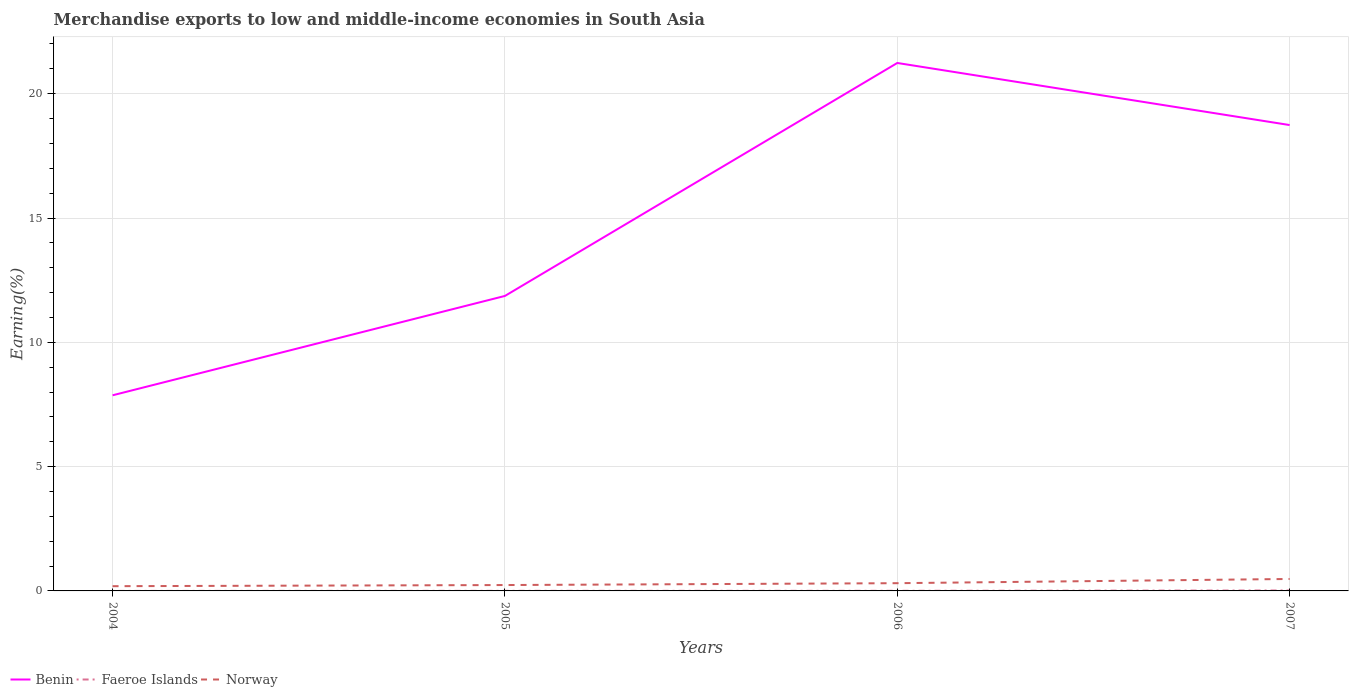Does the line corresponding to Faeroe Islands intersect with the line corresponding to Norway?
Give a very brief answer. No. Across all years, what is the maximum percentage of amount earned from merchandise exports in Faeroe Islands?
Your response must be concise. 0. In which year was the percentage of amount earned from merchandise exports in Faeroe Islands maximum?
Offer a very short reply. 2004. What is the total percentage of amount earned from merchandise exports in Benin in the graph?
Ensure brevity in your answer.  -13.37. What is the difference between the highest and the second highest percentage of amount earned from merchandise exports in Benin?
Ensure brevity in your answer.  13.37. What is the difference between the highest and the lowest percentage of amount earned from merchandise exports in Norway?
Your answer should be very brief. 2. Is the percentage of amount earned from merchandise exports in Benin strictly greater than the percentage of amount earned from merchandise exports in Faeroe Islands over the years?
Offer a very short reply. No. How many years are there in the graph?
Offer a very short reply. 4. What is the difference between two consecutive major ticks on the Y-axis?
Make the answer very short. 5. Does the graph contain grids?
Give a very brief answer. Yes. What is the title of the graph?
Your answer should be very brief. Merchandise exports to low and middle-income economies in South Asia. What is the label or title of the Y-axis?
Your response must be concise. Earning(%). What is the Earning(%) in Benin in 2004?
Give a very brief answer. 7.87. What is the Earning(%) in Faeroe Islands in 2004?
Offer a terse response. 0. What is the Earning(%) in Norway in 2004?
Give a very brief answer. 0.19. What is the Earning(%) of Benin in 2005?
Offer a very short reply. 11.86. What is the Earning(%) in Faeroe Islands in 2005?
Provide a succinct answer. 0. What is the Earning(%) of Norway in 2005?
Keep it short and to the point. 0.24. What is the Earning(%) in Benin in 2006?
Provide a short and direct response. 21.24. What is the Earning(%) of Faeroe Islands in 2006?
Keep it short and to the point. 0. What is the Earning(%) in Norway in 2006?
Offer a very short reply. 0.31. What is the Earning(%) of Benin in 2007?
Ensure brevity in your answer.  18.74. What is the Earning(%) of Faeroe Islands in 2007?
Offer a very short reply. 0.02. What is the Earning(%) in Norway in 2007?
Your response must be concise. 0.48. Across all years, what is the maximum Earning(%) of Benin?
Provide a succinct answer. 21.24. Across all years, what is the maximum Earning(%) of Faeroe Islands?
Your response must be concise. 0.02. Across all years, what is the maximum Earning(%) of Norway?
Ensure brevity in your answer.  0.48. Across all years, what is the minimum Earning(%) in Benin?
Your answer should be compact. 7.87. Across all years, what is the minimum Earning(%) in Faeroe Islands?
Provide a succinct answer. 0. Across all years, what is the minimum Earning(%) in Norway?
Provide a short and direct response. 0.19. What is the total Earning(%) of Benin in the graph?
Provide a succinct answer. 59.71. What is the total Earning(%) of Faeroe Islands in the graph?
Your response must be concise. 0.03. What is the total Earning(%) in Norway in the graph?
Provide a succinct answer. 1.22. What is the difference between the Earning(%) in Benin in 2004 and that in 2005?
Offer a terse response. -4. What is the difference between the Earning(%) of Faeroe Islands in 2004 and that in 2005?
Ensure brevity in your answer.  -0. What is the difference between the Earning(%) in Norway in 2004 and that in 2005?
Offer a terse response. -0.05. What is the difference between the Earning(%) of Benin in 2004 and that in 2006?
Provide a succinct answer. -13.37. What is the difference between the Earning(%) of Faeroe Islands in 2004 and that in 2006?
Offer a very short reply. -0. What is the difference between the Earning(%) in Norway in 2004 and that in 2006?
Your response must be concise. -0.12. What is the difference between the Earning(%) in Benin in 2004 and that in 2007?
Offer a very short reply. -10.87. What is the difference between the Earning(%) of Faeroe Islands in 2004 and that in 2007?
Keep it short and to the point. -0.02. What is the difference between the Earning(%) in Norway in 2004 and that in 2007?
Offer a very short reply. -0.29. What is the difference between the Earning(%) in Benin in 2005 and that in 2006?
Ensure brevity in your answer.  -9.37. What is the difference between the Earning(%) in Faeroe Islands in 2005 and that in 2006?
Make the answer very short. -0. What is the difference between the Earning(%) in Norway in 2005 and that in 2006?
Provide a succinct answer. -0.07. What is the difference between the Earning(%) of Benin in 2005 and that in 2007?
Your answer should be very brief. -6.87. What is the difference between the Earning(%) in Faeroe Islands in 2005 and that in 2007?
Your response must be concise. -0.01. What is the difference between the Earning(%) in Norway in 2005 and that in 2007?
Provide a short and direct response. -0.24. What is the difference between the Earning(%) in Benin in 2006 and that in 2007?
Your response must be concise. 2.5. What is the difference between the Earning(%) of Faeroe Islands in 2006 and that in 2007?
Your response must be concise. -0.01. What is the difference between the Earning(%) of Norway in 2006 and that in 2007?
Provide a succinct answer. -0.17. What is the difference between the Earning(%) in Benin in 2004 and the Earning(%) in Faeroe Islands in 2005?
Provide a succinct answer. 7.86. What is the difference between the Earning(%) of Benin in 2004 and the Earning(%) of Norway in 2005?
Offer a very short reply. 7.63. What is the difference between the Earning(%) in Faeroe Islands in 2004 and the Earning(%) in Norway in 2005?
Make the answer very short. -0.24. What is the difference between the Earning(%) of Benin in 2004 and the Earning(%) of Faeroe Islands in 2006?
Keep it short and to the point. 7.86. What is the difference between the Earning(%) of Benin in 2004 and the Earning(%) of Norway in 2006?
Offer a terse response. 7.56. What is the difference between the Earning(%) of Faeroe Islands in 2004 and the Earning(%) of Norway in 2006?
Provide a succinct answer. -0.31. What is the difference between the Earning(%) in Benin in 2004 and the Earning(%) in Faeroe Islands in 2007?
Your answer should be very brief. 7.85. What is the difference between the Earning(%) in Benin in 2004 and the Earning(%) in Norway in 2007?
Your answer should be very brief. 7.39. What is the difference between the Earning(%) in Faeroe Islands in 2004 and the Earning(%) in Norway in 2007?
Provide a succinct answer. -0.48. What is the difference between the Earning(%) in Benin in 2005 and the Earning(%) in Faeroe Islands in 2006?
Provide a succinct answer. 11.86. What is the difference between the Earning(%) in Benin in 2005 and the Earning(%) in Norway in 2006?
Offer a very short reply. 11.55. What is the difference between the Earning(%) of Faeroe Islands in 2005 and the Earning(%) of Norway in 2006?
Ensure brevity in your answer.  -0.31. What is the difference between the Earning(%) of Benin in 2005 and the Earning(%) of Faeroe Islands in 2007?
Provide a short and direct response. 11.85. What is the difference between the Earning(%) of Benin in 2005 and the Earning(%) of Norway in 2007?
Keep it short and to the point. 11.38. What is the difference between the Earning(%) in Faeroe Islands in 2005 and the Earning(%) in Norway in 2007?
Offer a very short reply. -0.48. What is the difference between the Earning(%) in Benin in 2006 and the Earning(%) in Faeroe Islands in 2007?
Your response must be concise. 21.22. What is the difference between the Earning(%) in Benin in 2006 and the Earning(%) in Norway in 2007?
Offer a terse response. 20.76. What is the difference between the Earning(%) of Faeroe Islands in 2006 and the Earning(%) of Norway in 2007?
Offer a terse response. -0.48. What is the average Earning(%) in Benin per year?
Keep it short and to the point. 14.93. What is the average Earning(%) in Faeroe Islands per year?
Make the answer very short. 0.01. What is the average Earning(%) in Norway per year?
Your answer should be very brief. 0.3. In the year 2004, what is the difference between the Earning(%) in Benin and Earning(%) in Faeroe Islands?
Provide a succinct answer. 7.87. In the year 2004, what is the difference between the Earning(%) of Benin and Earning(%) of Norway?
Provide a succinct answer. 7.68. In the year 2004, what is the difference between the Earning(%) in Faeroe Islands and Earning(%) in Norway?
Give a very brief answer. -0.19. In the year 2005, what is the difference between the Earning(%) in Benin and Earning(%) in Faeroe Islands?
Make the answer very short. 11.86. In the year 2005, what is the difference between the Earning(%) in Benin and Earning(%) in Norway?
Provide a succinct answer. 11.63. In the year 2005, what is the difference between the Earning(%) of Faeroe Islands and Earning(%) of Norway?
Keep it short and to the point. -0.23. In the year 2006, what is the difference between the Earning(%) in Benin and Earning(%) in Faeroe Islands?
Ensure brevity in your answer.  21.23. In the year 2006, what is the difference between the Earning(%) of Benin and Earning(%) of Norway?
Provide a succinct answer. 20.92. In the year 2006, what is the difference between the Earning(%) of Faeroe Islands and Earning(%) of Norway?
Provide a short and direct response. -0.31. In the year 2007, what is the difference between the Earning(%) in Benin and Earning(%) in Faeroe Islands?
Make the answer very short. 18.72. In the year 2007, what is the difference between the Earning(%) of Benin and Earning(%) of Norway?
Provide a succinct answer. 18.26. In the year 2007, what is the difference between the Earning(%) of Faeroe Islands and Earning(%) of Norway?
Your answer should be very brief. -0.46. What is the ratio of the Earning(%) in Benin in 2004 to that in 2005?
Ensure brevity in your answer.  0.66. What is the ratio of the Earning(%) of Faeroe Islands in 2004 to that in 2005?
Ensure brevity in your answer.  0.08. What is the ratio of the Earning(%) in Norway in 2004 to that in 2005?
Keep it short and to the point. 0.81. What is the ratio of the Earning(%) of Benin in 2004 to that in 2006?
Make the answer very short. 0.37. What is the ratio of the Earning(%) of Faeroe Islands in 2004 to that in 2006?
Make the answer very short. 0.06. What is the ratio of the Earning(%) of Norway in 2004 to that in 2006?
Make the answer very short. 0.61. What is the ratio of the Earning(%) of Benin in 2004 to that in 2007?
Keep it short and to the point. 0.42. What is the ratio of the Earning(%) of Faeroe Islands in 2004 to that in 2007?
Your response must be concise. 0.02. What is the ratio of the Earning(%) in Norway in 2004 to that in 2007?
Your answer should be compact. 0.4. What is the ratio of the Earning(%) of Benin in 2005 to that in 2006?
Offer a very short reply. 0.56. What is the ratio of the Earning(%) in Faeroe Islands in 2005 to that in 2006?
Provide a short and direct response. 0.73. What is the ratio of the Earning(%) in Norway in 2005 to that in 2006?
Offer a very short reply. 0.76. What is the ratio of the Earning(%) of Benin in 2005 to that in 2007?
Your answer should be compact. 0.63. What is the ratio of the Earning(%) in Faeroe Islands in 2005 to that in 2007?
Offer a very short reply. 0.19. What is the ratio of the Earning(%) in Norway in 2005 to that in 2007?
Offer a very short reply. 0.49. What is the ratio of the Earning(%) of Benin in 2006 to that in 2007?
Give a very brief answer. 1.13. What is the ratio of the Earning(%) in Faeroe Islands in 2006 to that in 2007?
Ensure brevity in your answer.  0.26. What is the ratio of the Earning(%) in Norway in 2006 to that in 2007?
Provide a succinct answer. 0.65. What is the difference between the highest and the second highest Earning(%) in Benin?
Offer a terse response. 2.5. What is the difference between the highest and the second highest Earning(%) in Faeroe Islands?
Offer a terse response. 0.01. What is the difference between the highest and the second highest Earning(%) of Norway?
Offer a terse response. 0.17. What is the difference between the highest and the lowest Earning(%) of Benin?
Ensure brevity in your answer.  13.37. What is the difference between the highest and the lowest Earning(%) in Faeroe Islands?
Offer a very short reply. 0.02. What is the difference between the highest and the lowest Earning(%) of Norway?
Offer a terse response. 0.29. 